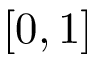Convert formula to latex. <formula><loc_0><loc_0><loc_500><loc_500>[ 0 , 1 ]</formula> 